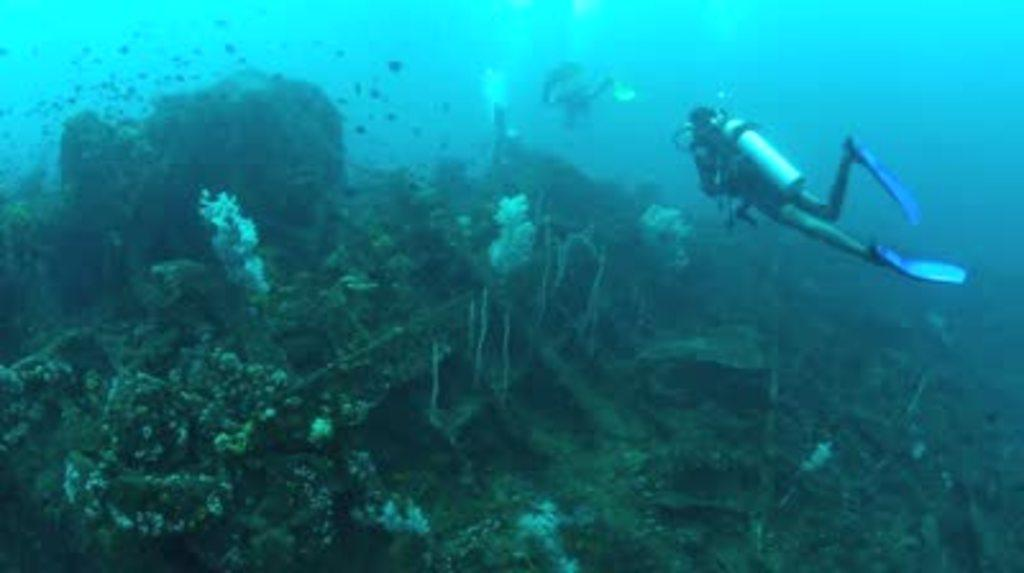What is the person in the image doing? The person is swimming in the water. What equipment is the person using while swimming? The person is wearing an oxygen cylinder. What type of underwater environment can be seen in the image? Corals are visible in the image. What is the name of the person swimming in the image? The provided facts do not include the name of the person swimming in the image. Can you tell me how many ploughs are visible in the image? There are no ploughs present in the image; it features a person swimming with an oxygen cylinder and corals in the background. 